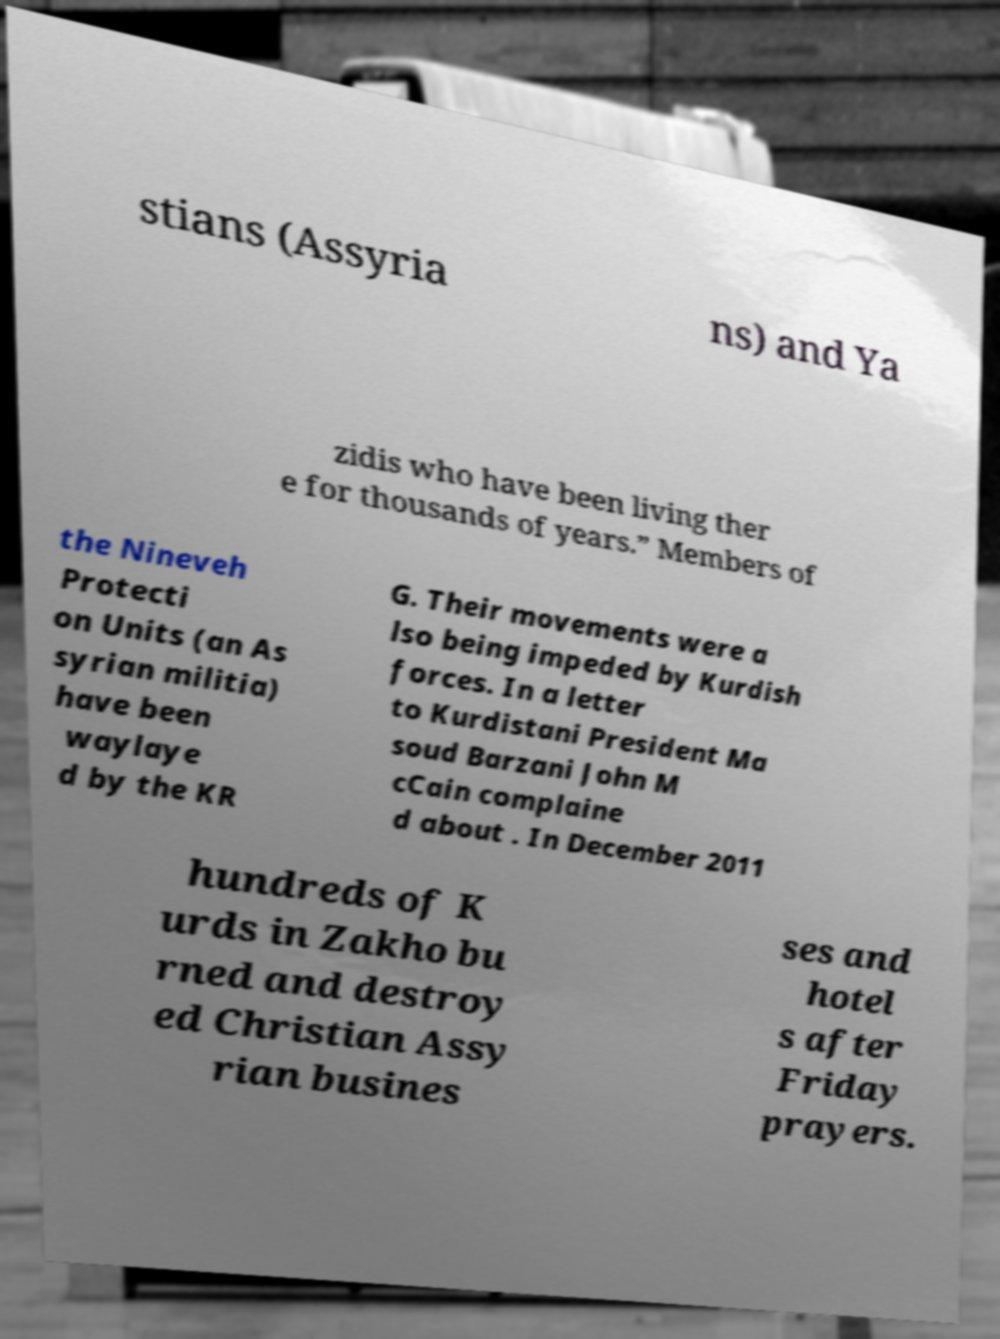Could you assist in decoding the text presented in this image and type it out clearly? stians (Assyria ns) and Ya zidis who have been living ther e for thousands of years.” Members of the Nineveh Protecti on Units (an As syrian militia) have been waylaye d by the KR G. Their movements were a lso being impeded by Kurdish forces. In a letter to Kurdistani President Ma soud Barzani John M cCain complaine d about . In December 2011 hundreds of K urds in Zakho bu rned and destroy ed Christian Assy rian busines ses and hotel s after Friday prayers. 